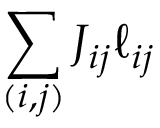<formula> <loc_0><loc_0><loc_500><loc_500>\sum _ { ( i , j ) } J _ { i j } \ell _ { i j }</formula> 